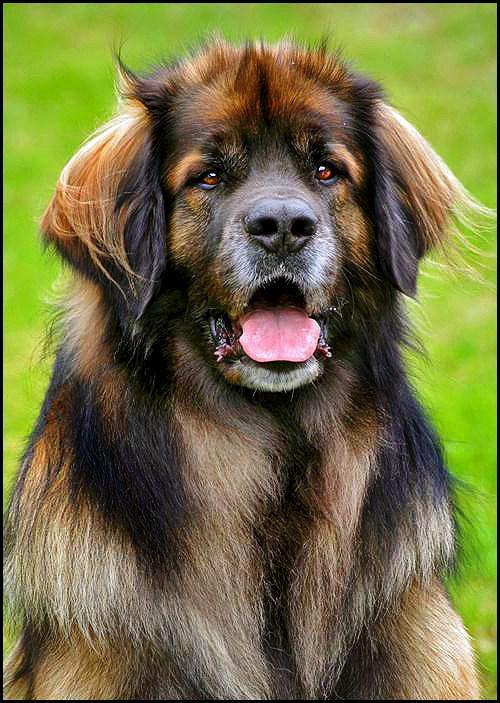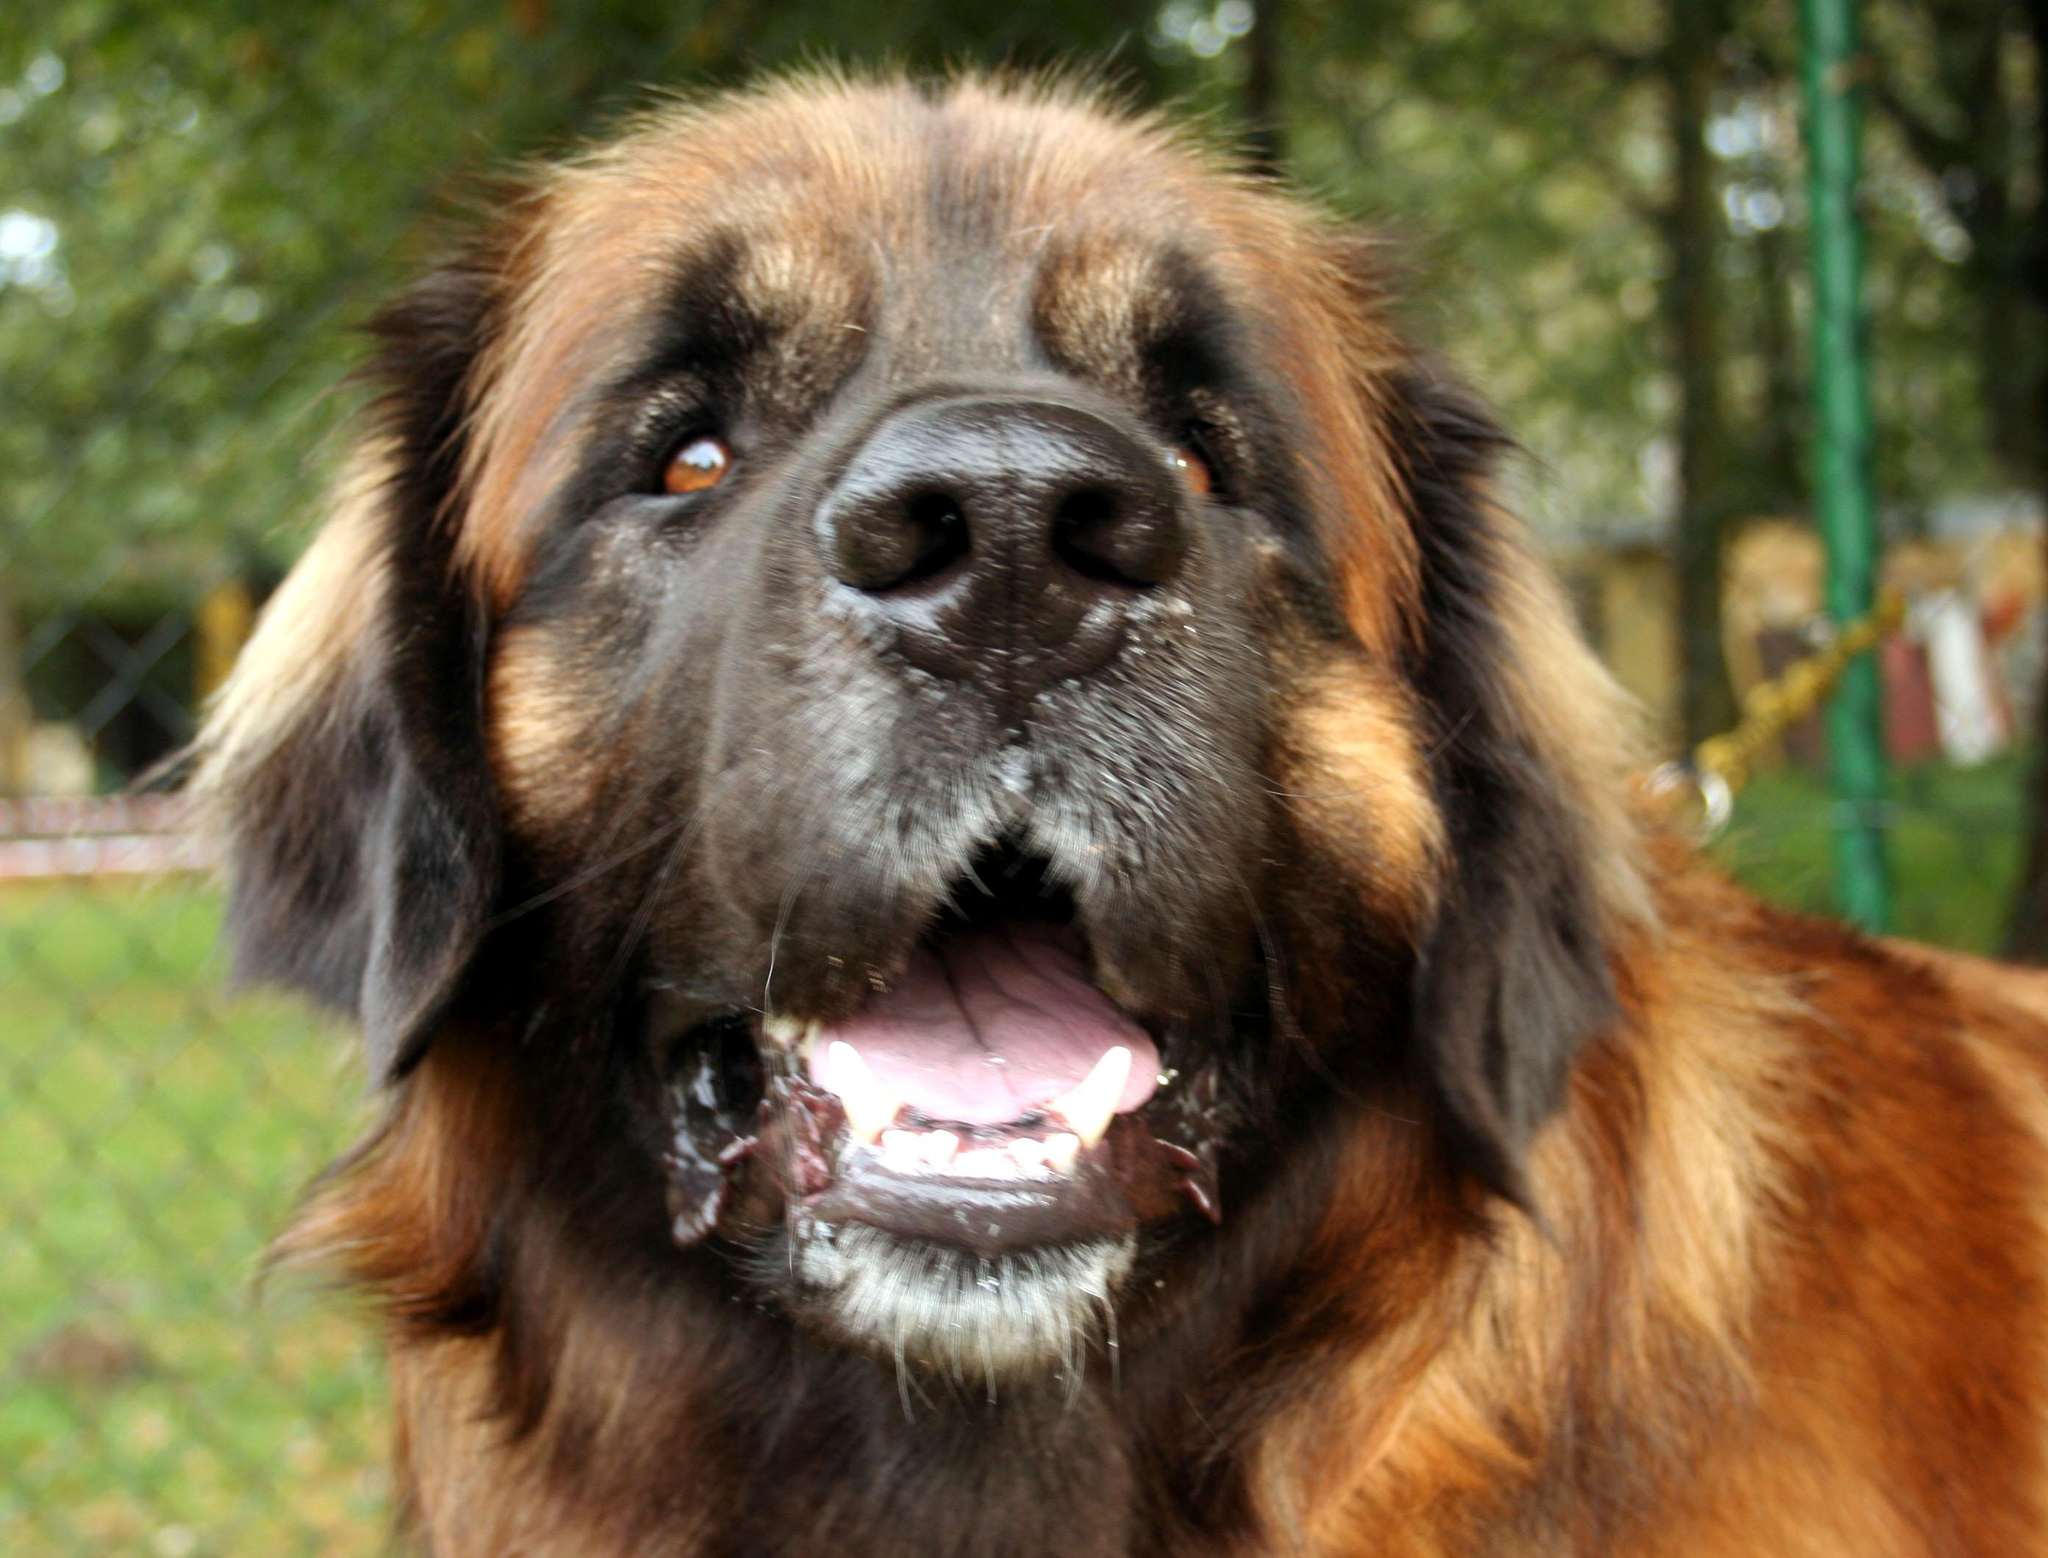The first image is the image on the left, the second image is the image on the right. For the images shown, is this caption "There is only one dog in each image and it has its mouth open." true? Answer yes or no. Yes. The first image is the image on the left, the second image is the image on the right. For the images displayed, is the sentence "All images show camera-facing dogs, and all dogs look similar in coloring and breed." factually correct? Answer yes or no. Yes. 